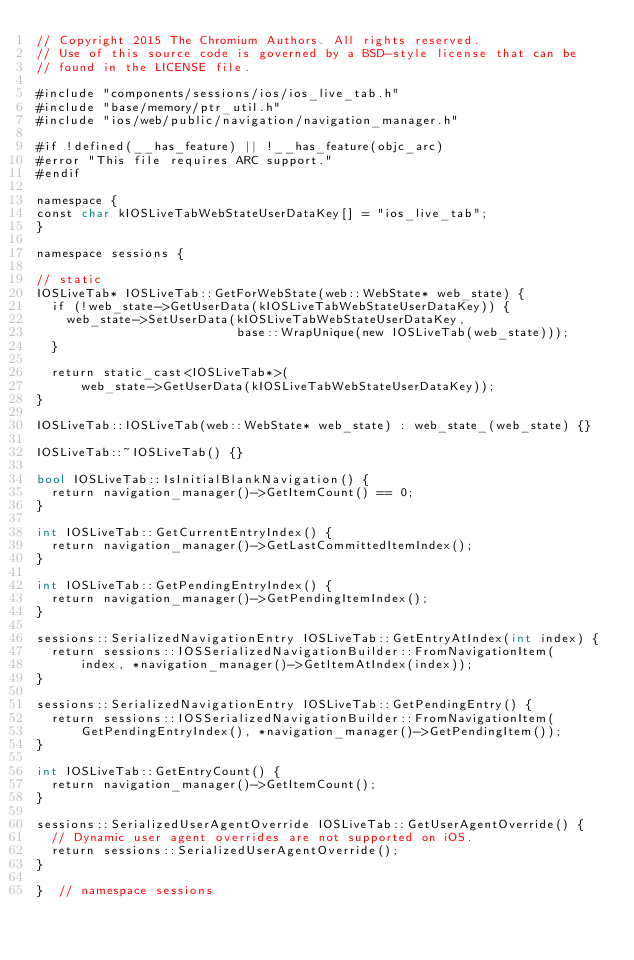Convert code to text. <code><loc_0><loc_0><loc_500><loc_500><_ObjectiveC_>// Copyright 2015 The Chromium Authors. All rights reserved.
// Use of this source code is governed by a BSD-style license that can be
// found in the LICENSE file.

#include "components/sessions/ios/ios_live_tab.h"
#include "base/memory/ptr_util.h"
#include "ios/web/public/navigation/navigation_manager.h"

#if !defined(__has_feature) || !__has_feature(objc_arc)
#error "This file requires ARC support."
#endif

namespace {
const char kIOSLiveTabWebStateUserDataKey[] = "ios_live_tab";
}

namespace sessions {

// static
IOSLiveTab* IOSLiveTab::GetForWebState(web::WebState* web_state) {
  if (!web_state->GetUserData(kIOSLiveTabWebStateUserDataKey)) {
    web_state->SetUserData(kIOSLiveTabWebStateUserDataKey,
                           base::WrapUnique(new IOSLiveTab(web_state)));
  }

  return static_cast<IOSLiveTab*>(
      web_state->GetUserData(kIOSLiveTabWebStateUserDataKey));
}

IOSLiveTab::IOSLiveTab(web::WebState* web_state) : web_state_(web_state) {}

IOSLiveTab::~IOSLiveTab() {}

bool IOSLiveTab::IsInitialBlankNavigation() {
  return navigation_manager()->GetItemCount() == 0;
}

int IOSLiveTab::GetCurrentEntryIndex() {
  return navigation_manager()->GetLastCommittedItemIndex();
}

int IOSLiveTab::GetPendingEntryIndex() {
  return navigation_manager()->GetPendingItemIndex();
}

sessions::SerializedNavigationEntry IOSLiveTab::GetEntryAtIndex(int index) {
  return sessions::IOSSerializedNavigationBuilder::FromNavigationItem(
      index, *navigation_manager()->GetItemAtIndex(index));
}

sessions::SerializedNavigationEntry IOSLiveTab::GetPendingEntry() {
  return sessions::IOSSerializedNavigationBuilder::FromNavigationItem(
      GetPendingEntryIndex(), *navigation_manager()->GetPendingItem());
}

int IOSLiveTab::GetEntryCount() {
  return navigation_manager()->GetItemCount();
}

sessions::SerializedUserAgentOverride IOSLiveTab::GetUserAgentOverride() {
  // Dynamic user agent overrides are not supported on iOS.
  return sessions::SerializedUserAgentOverride();
}

}  // namespace sessions
</code> 